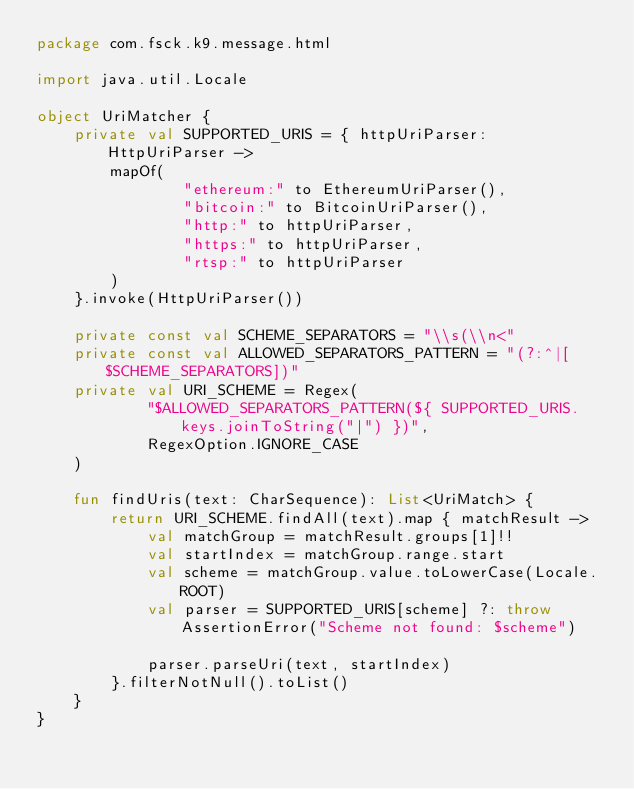<code> <loc_0><loc_0><loc_500><loc_500><_Kotlin_>package com.fsck.k9.message.html

import java.util.Locale

object UriMatcher {
    private val SUPPORTED_URIS = { httpUriParser: HttpUriParser ->
        mapOf(
                "ethereum:" to EthereumUriParser(),
                "bitcoin:" to BitcoinUriParser(),
                "http:" to httpUriParser,
                "https:" to httpUriParser,
                "rtsp:" to httpUriParser
        )
    }.invoke(HttpUriParser())

    private const val SCHEME_SEPARATORS = "\\s(\\n<"
    private const val ALLOWED_SEPARATORS_PATTERN = "(?:^|[$SCHEME_SEPARATORS])"
    private val URI_SCHEME = Regex(
            "$ALLOWED_SEPARATORS_PATTERN(${ SUPPORTED_URIS.keys.joinToString("|") })",
            RegexOption.IGNORE_CASE
    )

    fun findUris(text: CharSequence): List<UriMatch> {
        return URI_SCHEME.findAll(text).map { matchResult ->
            val matchGroup = matchResult.groups[1]!!
            val startIndex = matchGroup.range.start
            val scheme = matchGroup.value.toLowerCase(Locale.ROOT)
            val parser = SUPPORTED_URIS[scheme] ?: throw AssertionError("Scheme not found: $scheme")

            parser.parseUri(text, startIndex)
        }.filterNotNull().toList()
    }
}
</code> 